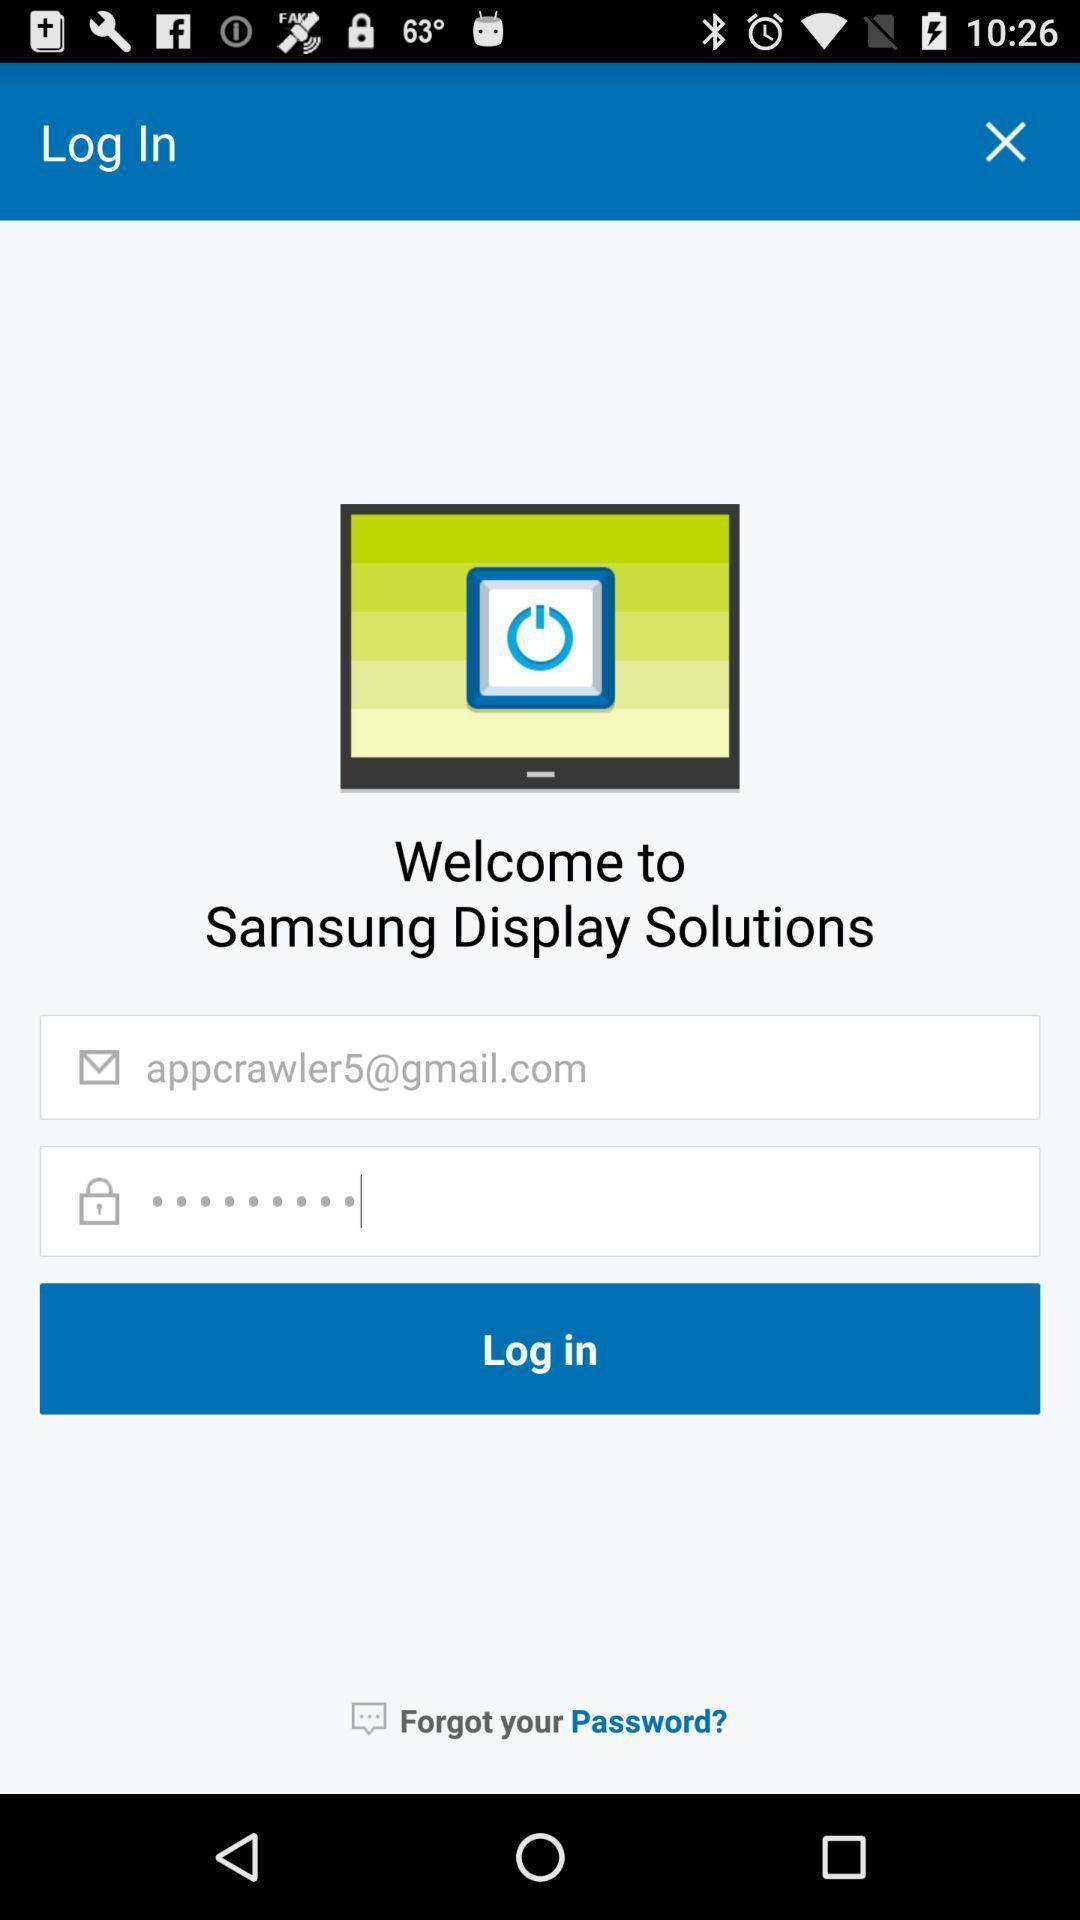Describe the visual elements of this screenshot. Page showing login page. 